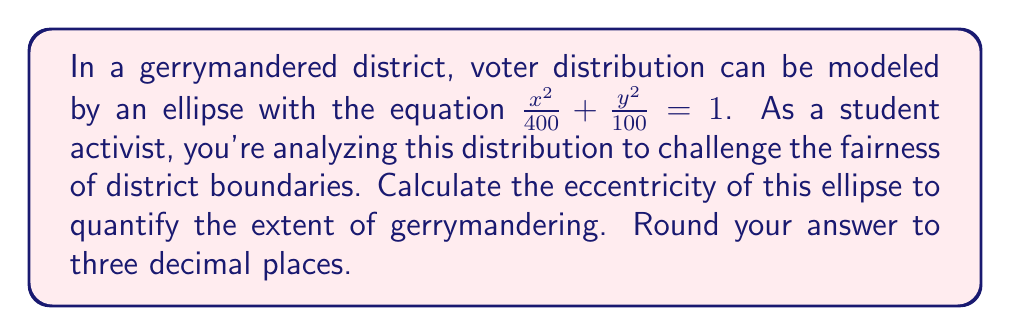Could you help me with this problem? Let's approach this step-by-step:

1) The general equation of an ellipse is $\frac{x^2}{a^2} + \frac{y^2}{b^2} = 1$, where $a$ and $b$ are the lengths of the semi-major and semi-minor axes respectively.

2) Comparing our equation $\frac{x^2}{400} + \frac{y^2}{100} = 1$ to the general form, we can identify:
   $a^2 = 400$ and $b^2 = 100$

3) Therefore, $a = \sqrt{400} = 20$ and $b = \sqrt{100} = 10$

4) The eccentricity (e) of an ellipse is given by the formula:

   $$e = \sqrt{1 - \frac{b^2}{a^2}}$$

5) Substituting our values:

   $$e = \sqrt{1 - \frac{10^2}{20^2}}$$

6) Simplify:
   $$e = \sqrt{1 - \frac{100}{400}} = \sqrt{1 - \frac{1}{4}} = \sqrt{\frac{3}{4}}$$

7) Calculate and round to three decimal places:
   $$e \approx 0.866$$

This high eccentricity (close to 1) indicates a very elongated ellipse, suggesting significant gerrymandering.
Answer: 0.866 